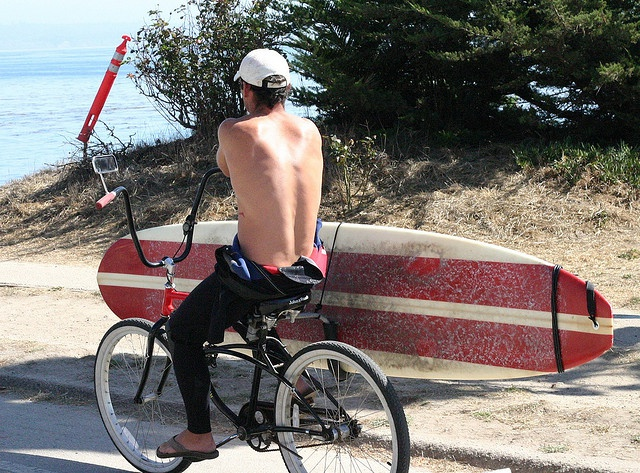Describe the objects in this image and their specific colors. I can see surfboard in white, maroon, brown, and darkgray tones, bicycle in white, black, gray, darkgray, and ivory tones, and people in white, black, and gray tones in this image. 